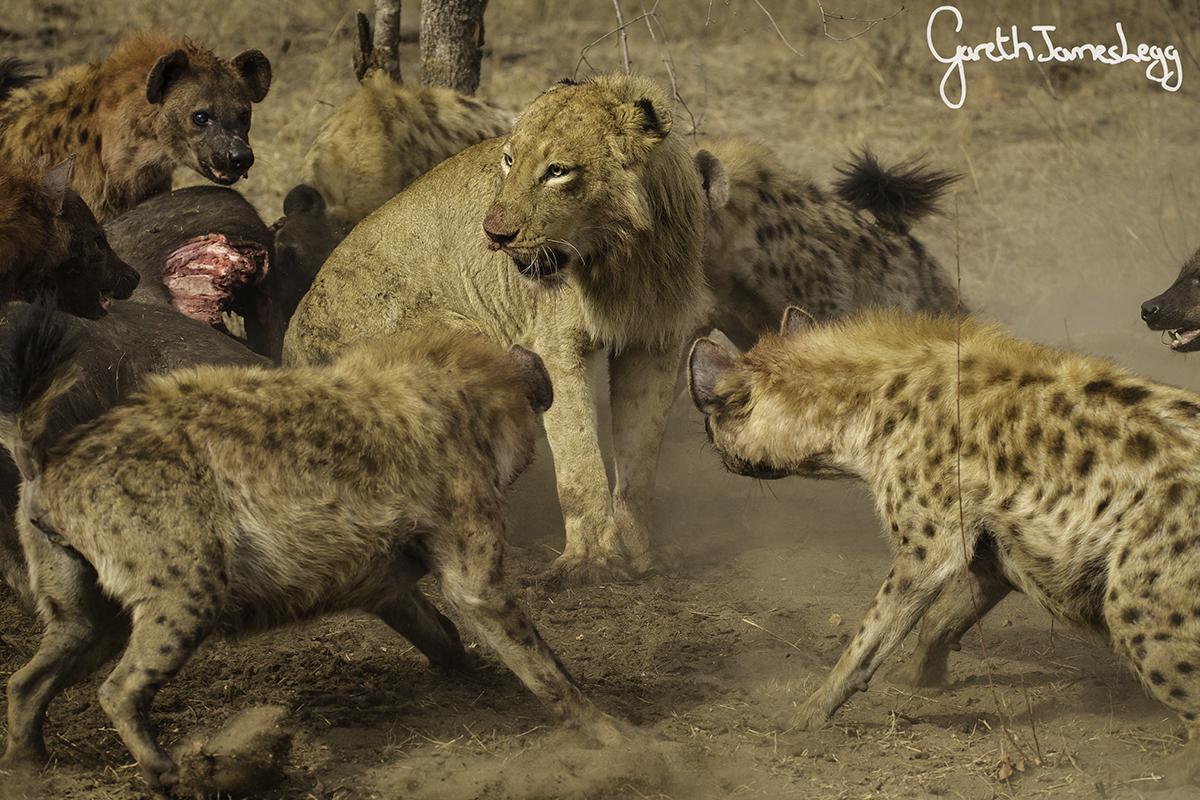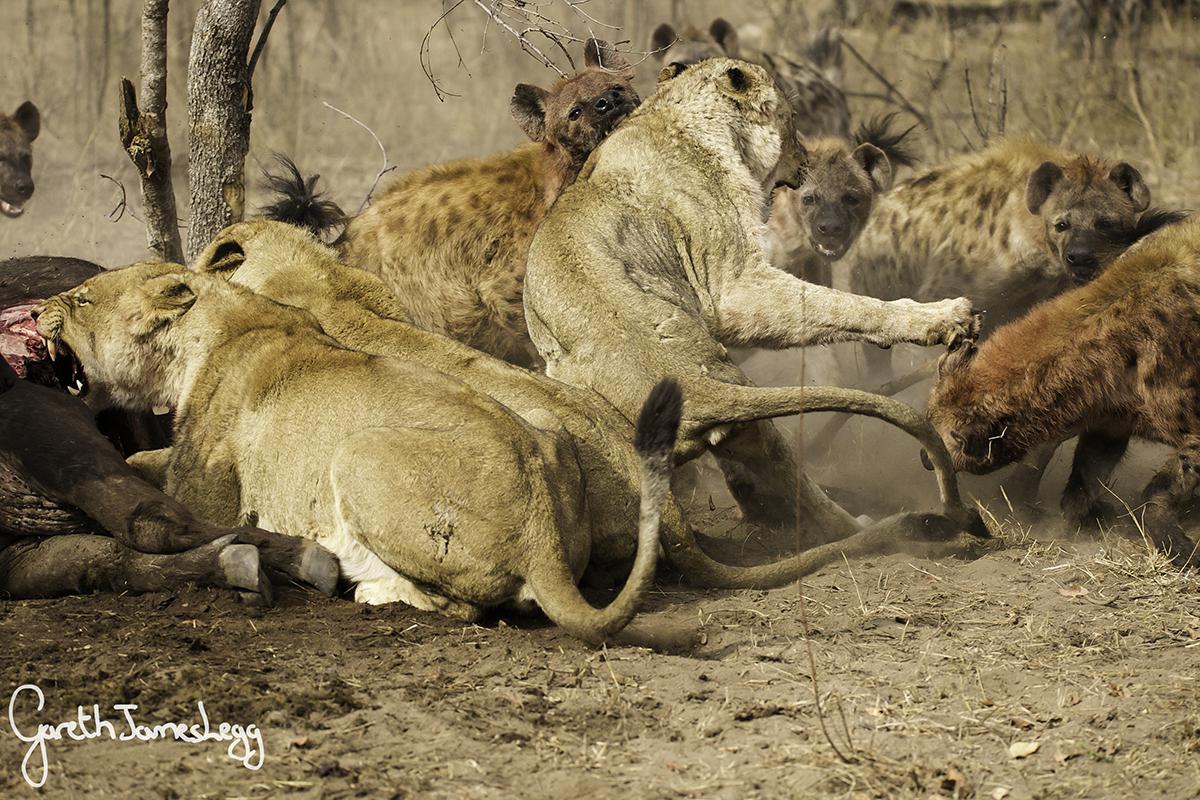The first image is the image on the left, the second image is the image on the right. Analyze the images presented: Is the assertion "A male lion is being attacked by hyenas." valid? Answer yes or no. Yes. The first image is the image on the left, the second image is the image on the right. Given the left and right images, does the statement "The right image contains no more than three hyenas." hold true? Answer yes or no. No. 